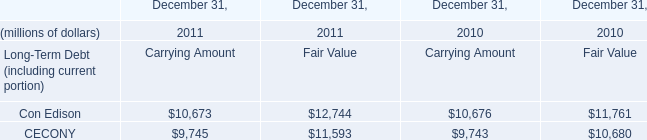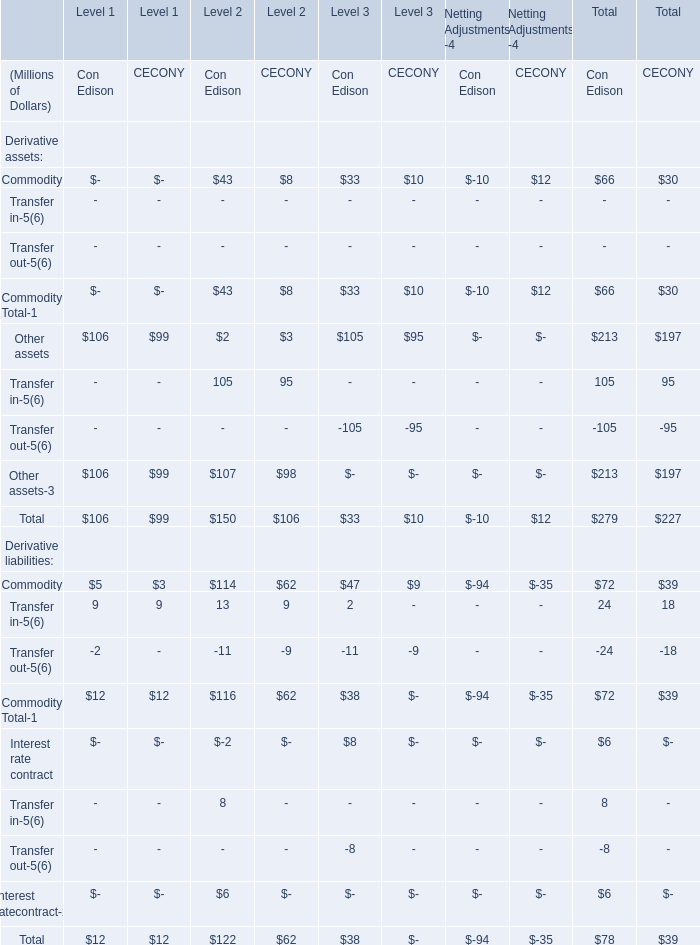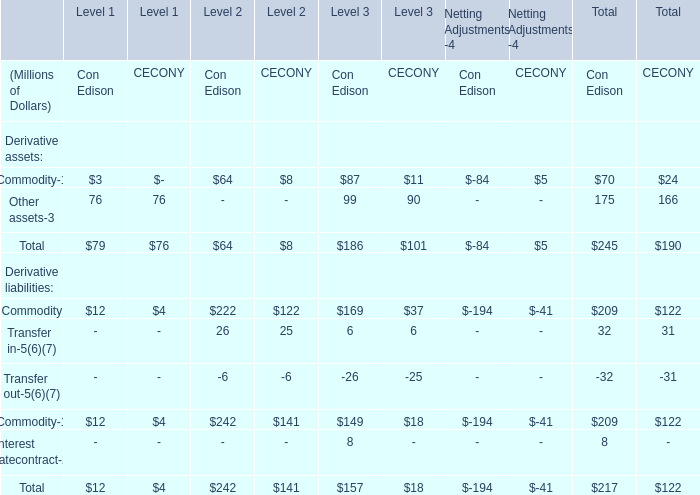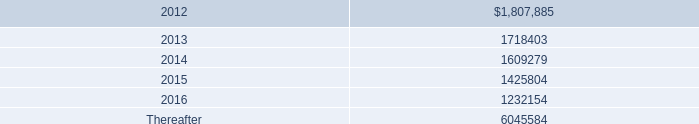What is the proportion of Other assets of Con Edison to the total for Derivative assets of Con Edison in terms of Level 1? 
Computations: (76 / 79)
Answer: 0.96203. 